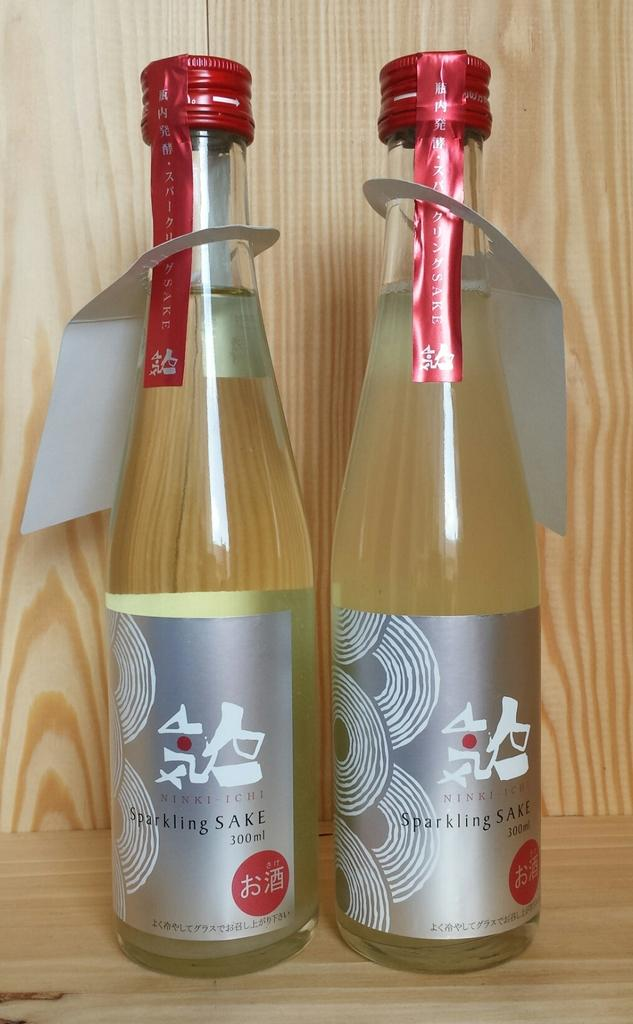What objects are present in the image that are made of glass? There are two glass bottles in the image. What type of bomb can be seen on the edge of the image? There is no bomb present in the image; it only features two glass bottles. 